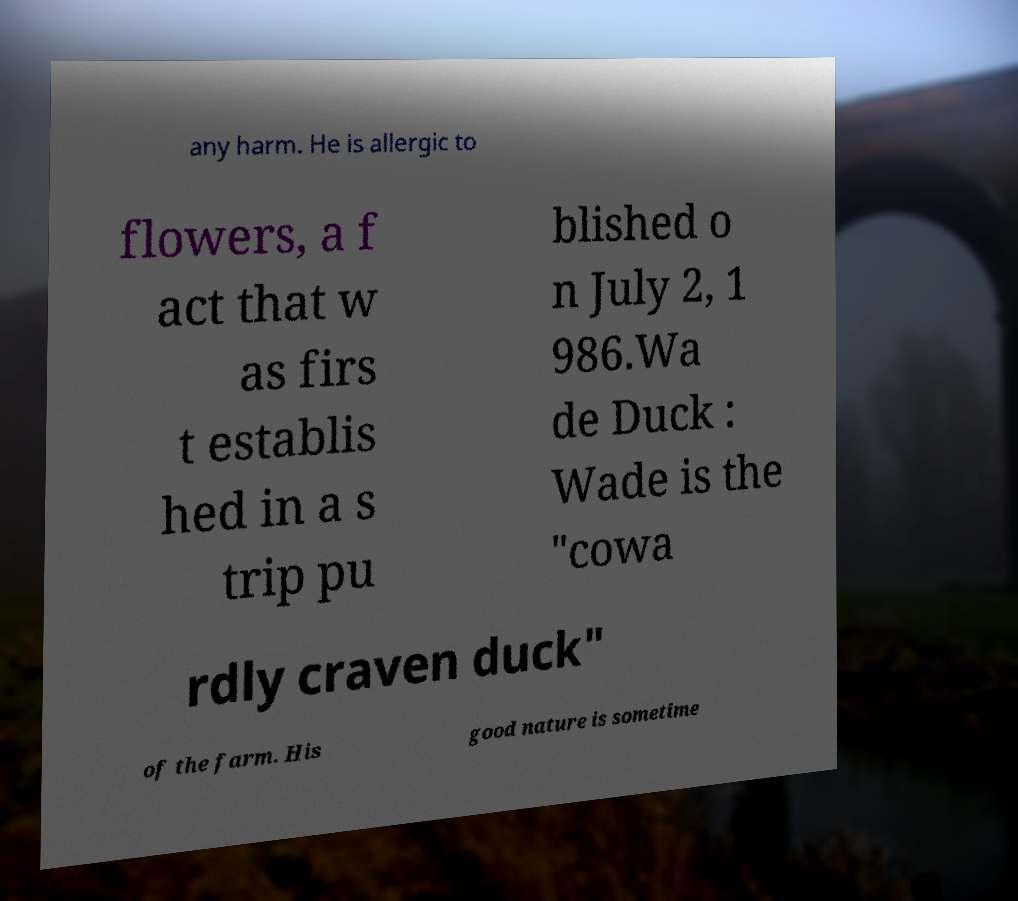For documentation purposes, I need the text within this image transcribed. Could you provide that? any harm. He is allergic to flowers, a f act that w as firs t establis hed in a s trip pu blished o n July 2, 1 986.Wa de Duck : Wade is the "cowa rdly craven duck" of the farm. His good nature is sometime 